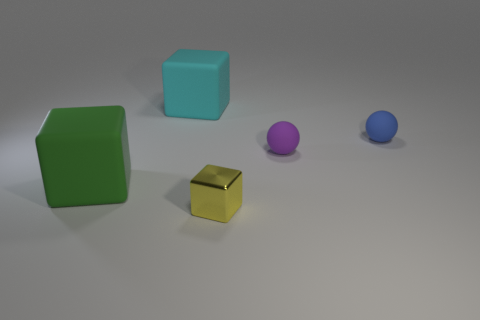There is a block that is to the left of the large matte object behind the green thing that is left of the cyan object; what is it made of?
Offer a very short reply. Rubber. Do the small object in front of the purple rubber ball and the green object have the same shape?
Offer a very short reply. Yes. What is the material of the tiny yellow object in front of the purple matte object?
Make the answer very short. Metal. How many rubber things are either purple objects or tiny yellow cubes?
Offer a very short reply. 1. Is there a blue shiny cylinder of the same size as the blue matte object?
Offer a terse response. No. Are there more rubber blocks that are in front of the cyan matte block than big red metal balls?
Make the answer very short. Yes. How many tiny objects are either cyan rubber blocks or balls?
Offer a very short reply. 2. How many green things are the same shape as the tiny yellow object?
Provide a succinct answer. 1. What material is the small object that is in front of the tiny sphere in front of the blue object?
Ensure brevity in your answer.  Metal. There is a block that is behind the purple object; what is its size?
Ensure brevity in your answer.  Large. 